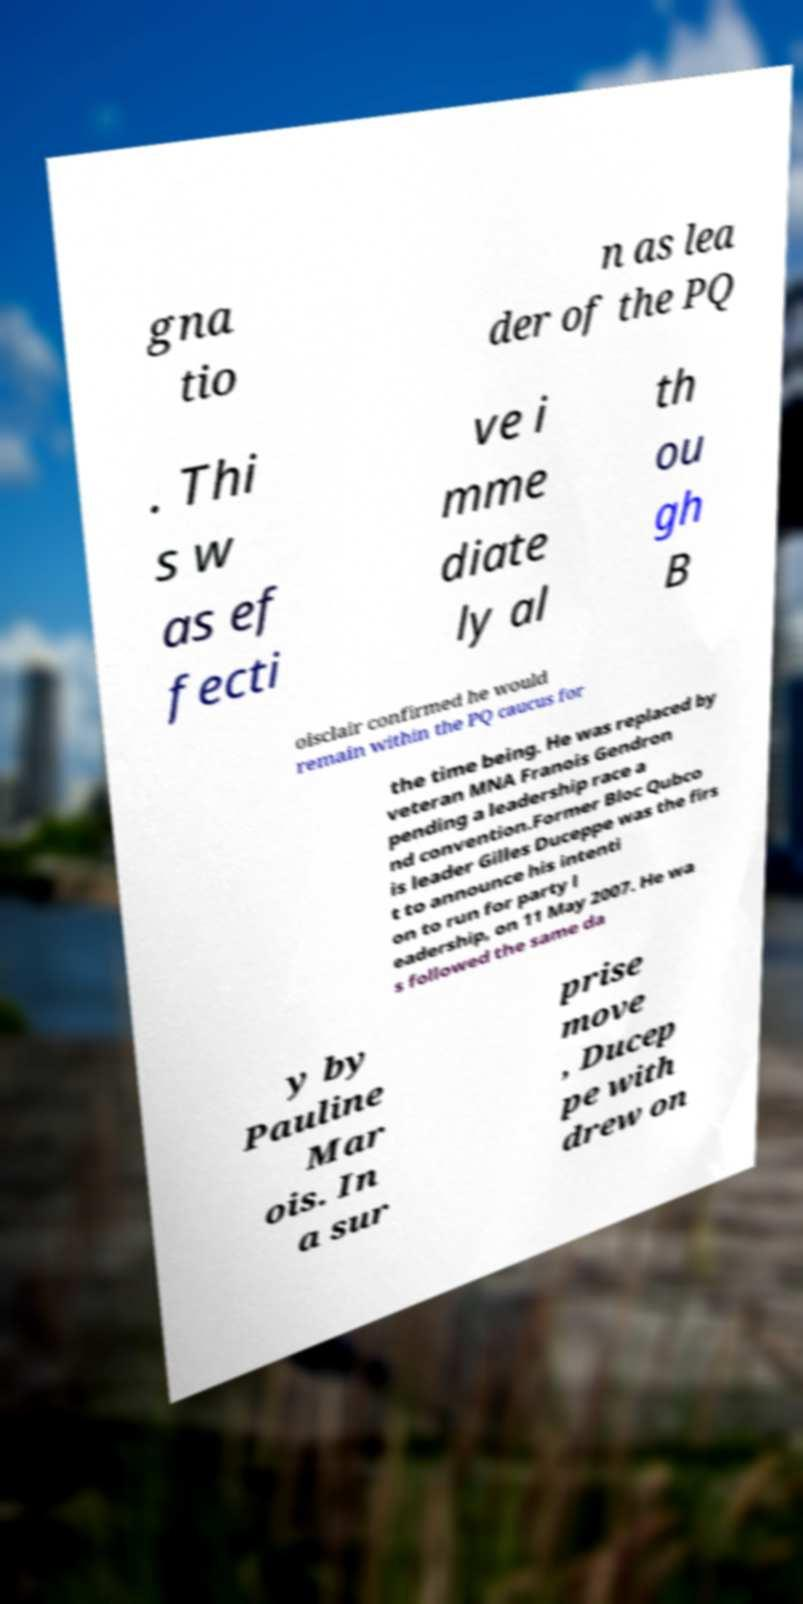For documentation purposes, I need the text within this image transcribed. Could you provide that? gna tio n as lea der of the PQ . Thi s w as ef fecti ve i mme diate ly al th ou gh B oisclair confirmed he would remain within the PQ caucus for the time being. He was replaced by veteran MNA Franois Gendron pending a leadership race a nd convention.Former Bloc Qubco is leader Gilles Duceppe was the firs t to announce his intenti on to run for party l eadership, on 11 May 2007. He wa s followed the same da y by Pauline Mar ois. In a sur prise move , Ducep pe with drew on 